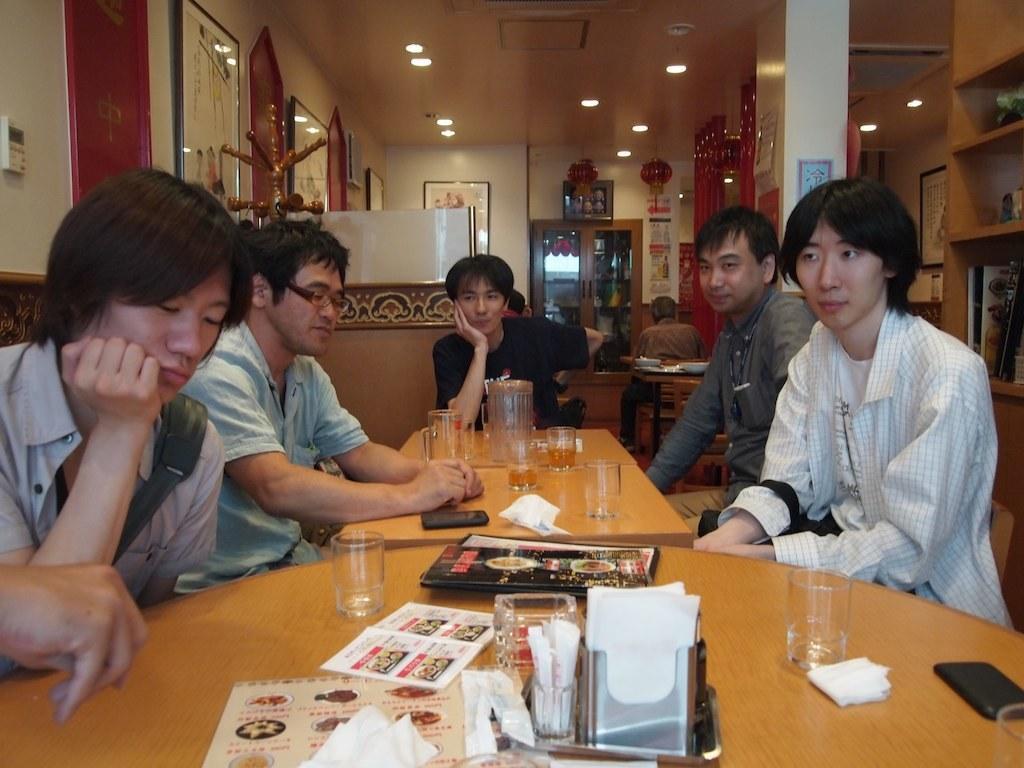Describe this image in one or two sentences. This picture is clicked inside room. Here, we see many people sitting on chair in front of table. On table, we see glass, book, paper, tissue papers, mobile phone and jar are placed on it and behind them, we see a wall is white in color and we see many photo frames placed on that wall. On the right corner we see a cupboard. 